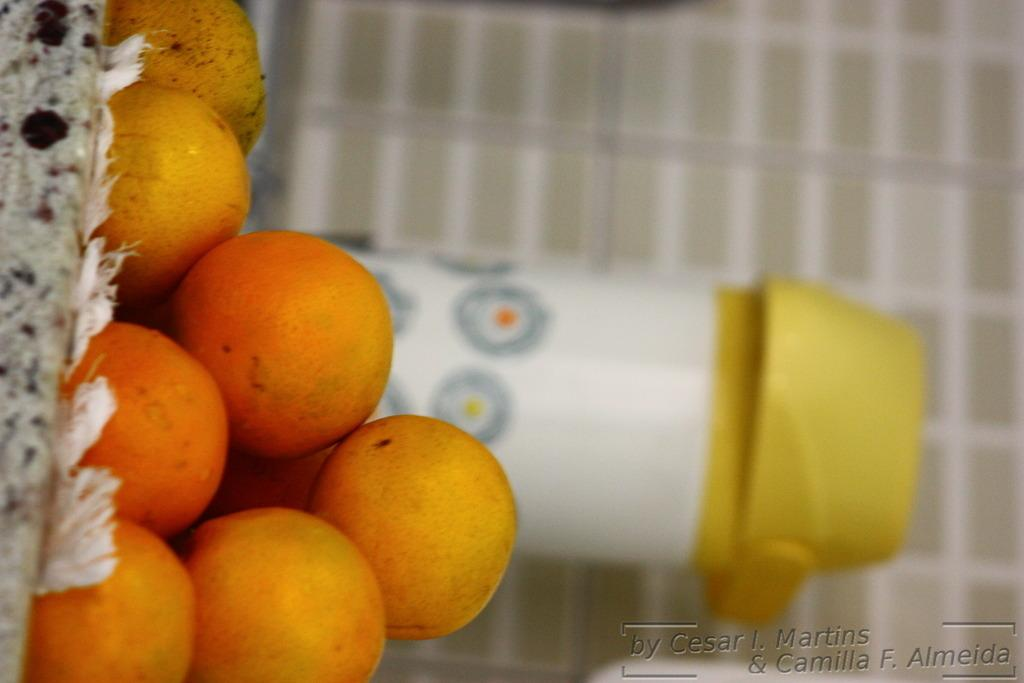What type of fruit is present in the image? There are oranges in the image. What other object can be seen in the image? There is a bottle in the image. What is visible in the background of the image? There is a wall in the background of the image. What type of committee is meeting in the image? There is no committee present in the image; it features oranges and a bottle. What kind of structure is visible in the image? There is no structure visible in the image; it only features oranges, a bottle, and a wall in the background. 